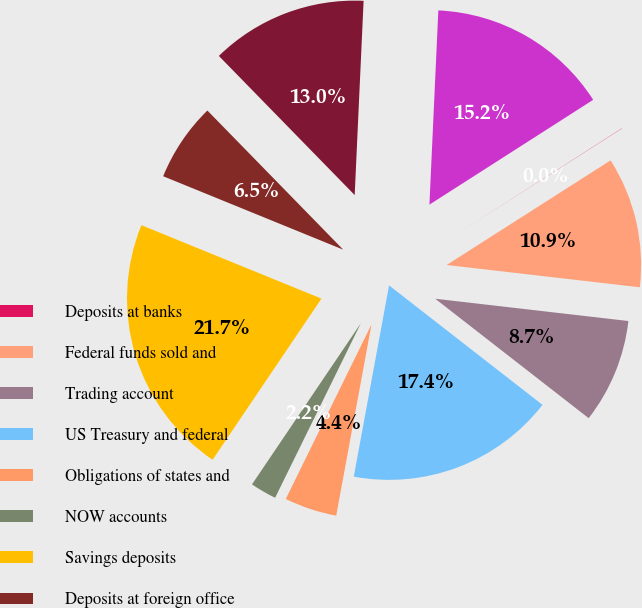Convert chart. <chart><loc_0><loc_0><loc_500><loc_500><pie_chart><fcel>Deposits at banks<fcel>Federal funds sold and<fcel>Trading account<fcel>US Treasury and federal<fcel>Obligations of states and<fcel>NOW accounts<fcel>Savings deposits<fcel>Deposits at foreign office<fcel>Short-term borrowings<fcel>Long-term borrowings<nl><fcel>0.02%<fcel>10.87%<fcel>8.7%<fcel>17.38%<fcel>4.36%<fcel>2.19%<fcel>21.71%<fcel>6.53%<fcel>13.04%<fcel>15.21%<nl></chart> 